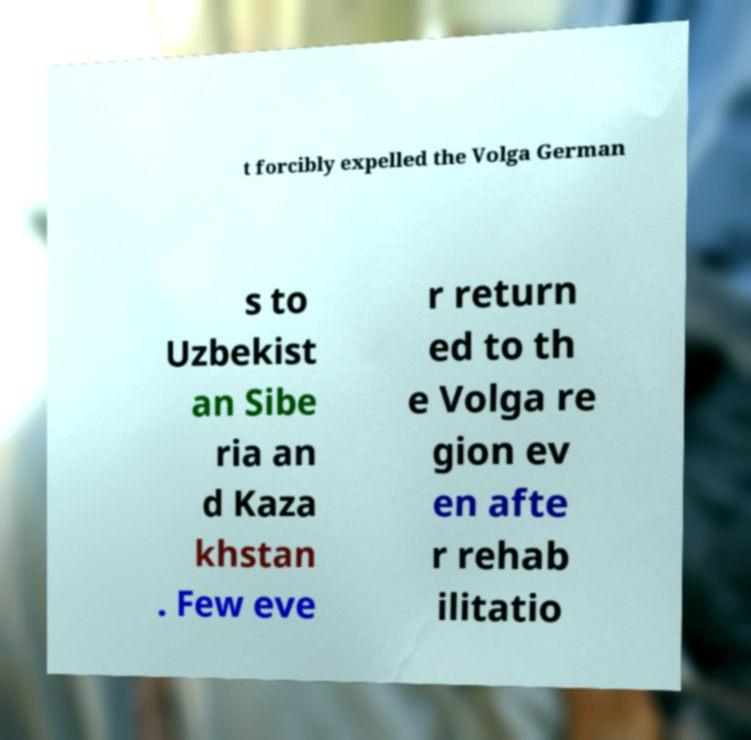Please read and relay the text visible in this image. What does it say? t forcibly expelled the Volga German s to Uzbekist an Sibe ria an d Kaza khstan . Few eve r return ed to th e Volga re gion ev en afte r rehab ilitatio 